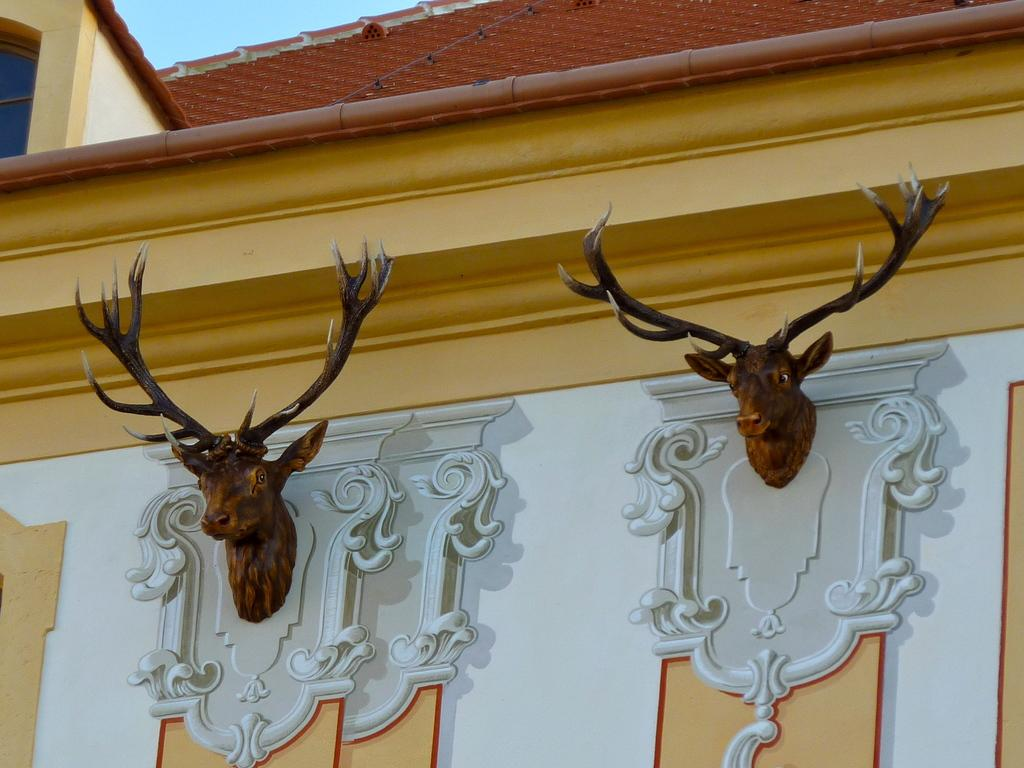What can be seen on the wall in the image? There are two sculptures on a wall in the image. What is visible at the top of the image? The roof is visible at the top of the image. What part of the natural environment is visible in the image? The sky is visible in the image. How much dust can be seen on the sculptures in the image? There is no mention of dust in the image, so it cannot be determined how much dust might be present on the sculptures. 